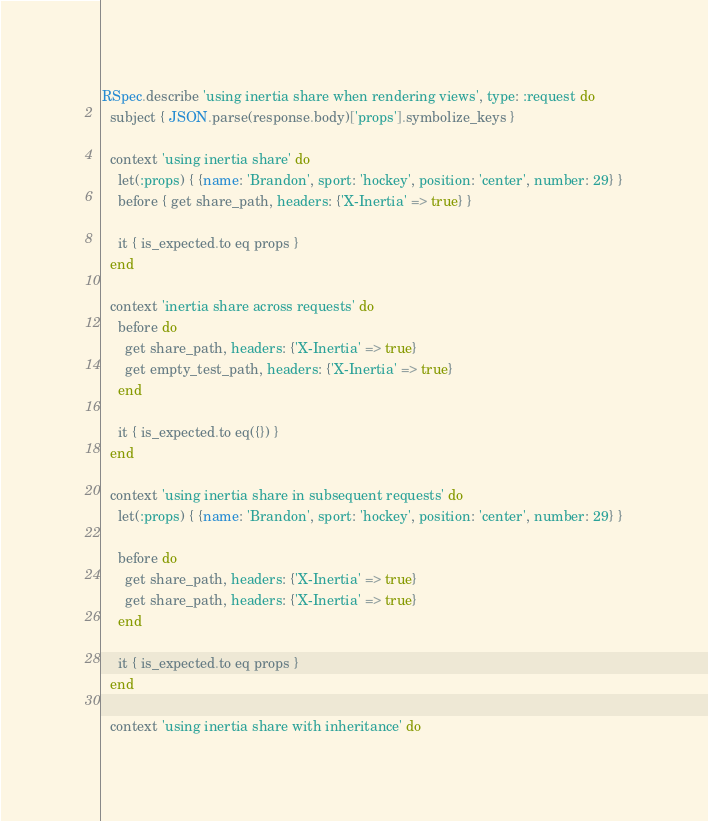Convert code to text. <code><loc_0><loc_0><loc_500><loc_500><_Ruby_>RSpec.describe 'using inertia share when rendering views', type: :request do
  subject { JSON.parse(response.body)['props'].symbolize_keys }

  context 'using inertia share' do
    let(:props) { {name: 'Brandon', sport: 'hockey', position: 'center', number: 29} }
    before { get share_path, headers: {'X-Inertia' => true} }

    it { is_expected.to eq props }
  end

  context 'inertia share across requests' do
    before do
      get share_path, headers: {'X-Inertia' => true}
      get empty_test_path, headers: {'X-Inertia' => true}
    end

    it { is_expected.to eq({}) }
  end

  context 'using inertia share in subsequent requests' do
    let(:props) { {name: 'Brandon', sport: 'hockey', position: 'center', number: 29} }

    before do
      get share_path, headers: {'X-Inertia' => true}
      get share_path, headers: {'X-Inertia' => true}
    end

    it { is_expected.to eq props }
  end

  context 'using inertia share with inheritance' do</code> 